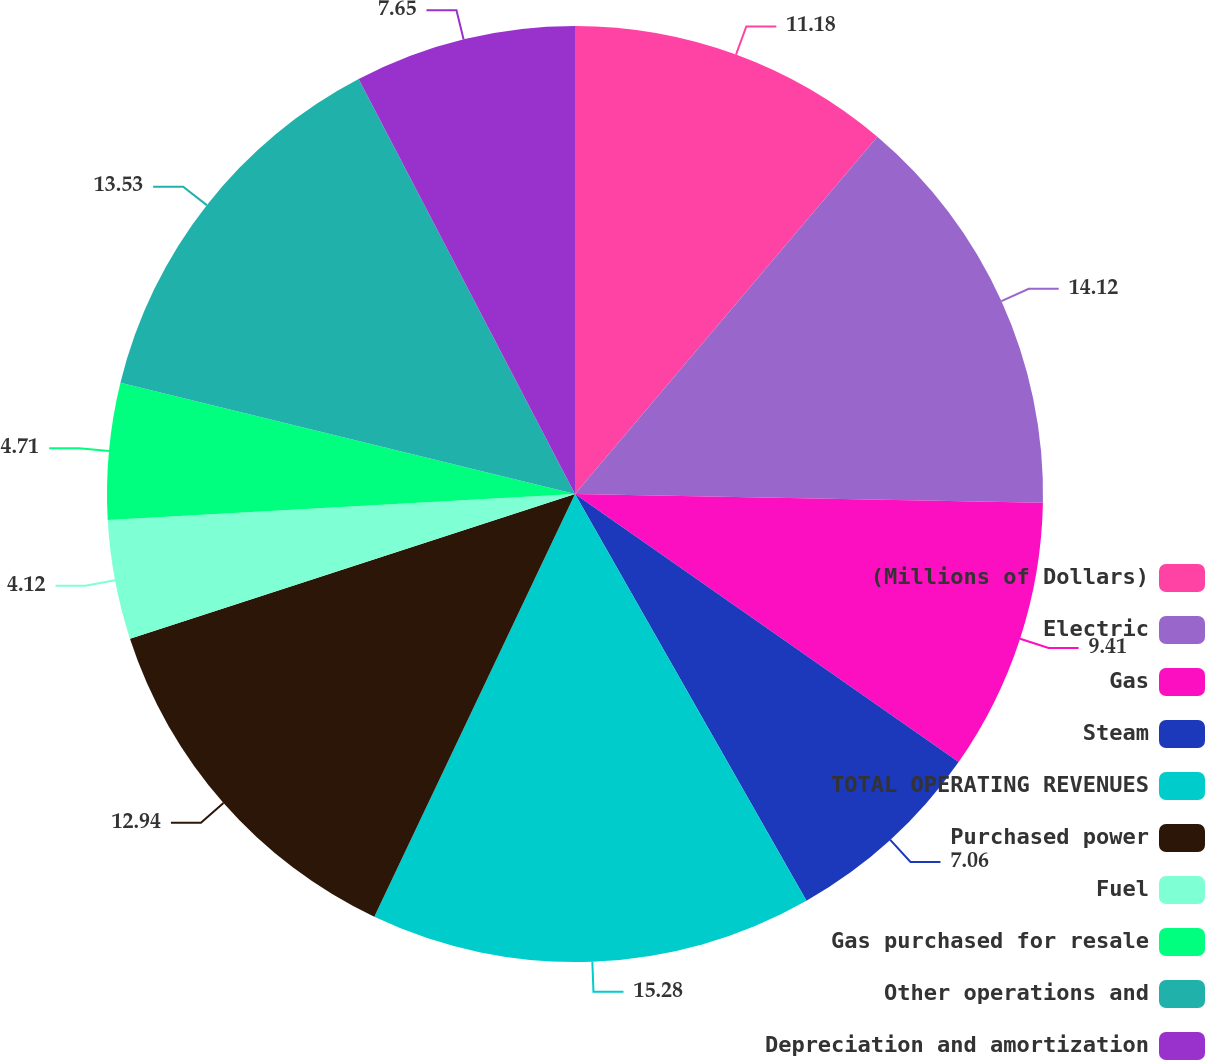Convert chart to OTSL. <chart><loc_0><loc_0><loc_500><loc_500><pie_chart><fcel>(Millions of Dollars)<fcel>Electric<fcel>Gas<fcel>Steam<fcel>TOTAL OPERATING REVENUES<fcel>Purchased power<fcel>Fuel<fcel>Gas purchased for resale<fcel>Other operations and<fcel>Depreciation and amortization<nl><fcel>11.18%<fcel>14.12%<fcel>9.41%<fcel>7.06%<fcel>15.29%<fcel>12.94%<fcel>4.12%<fcel>4.71%<fcel>13.53%<fcel>7.65%<nl></chart> 